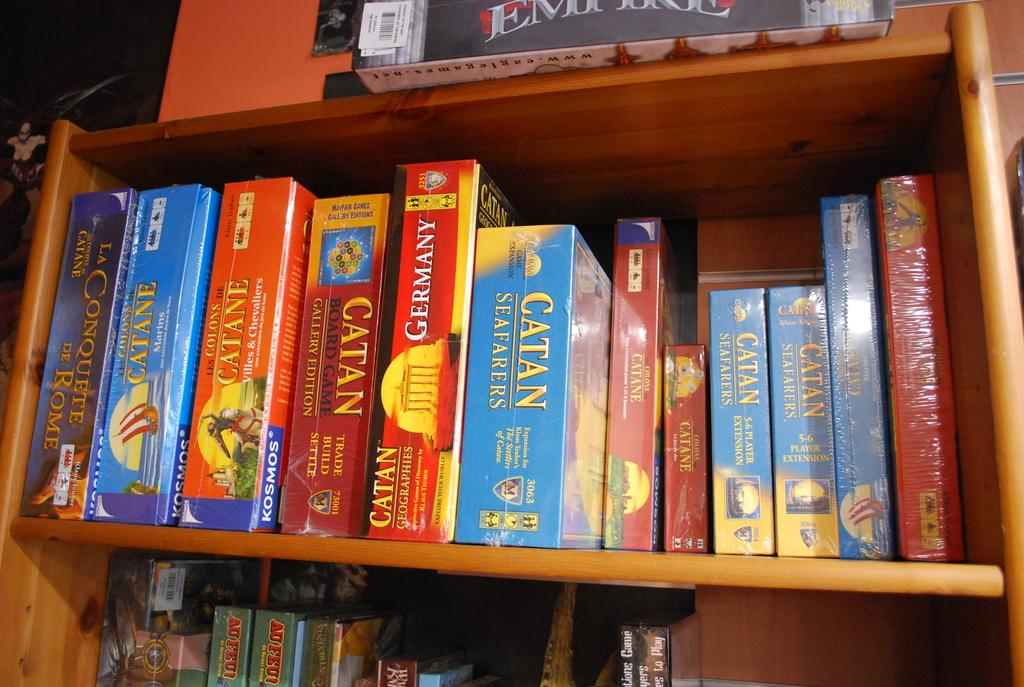Provide a one-sentence caption for the provided image. Several versions of the Catan board game sit lined up on a shelf. 